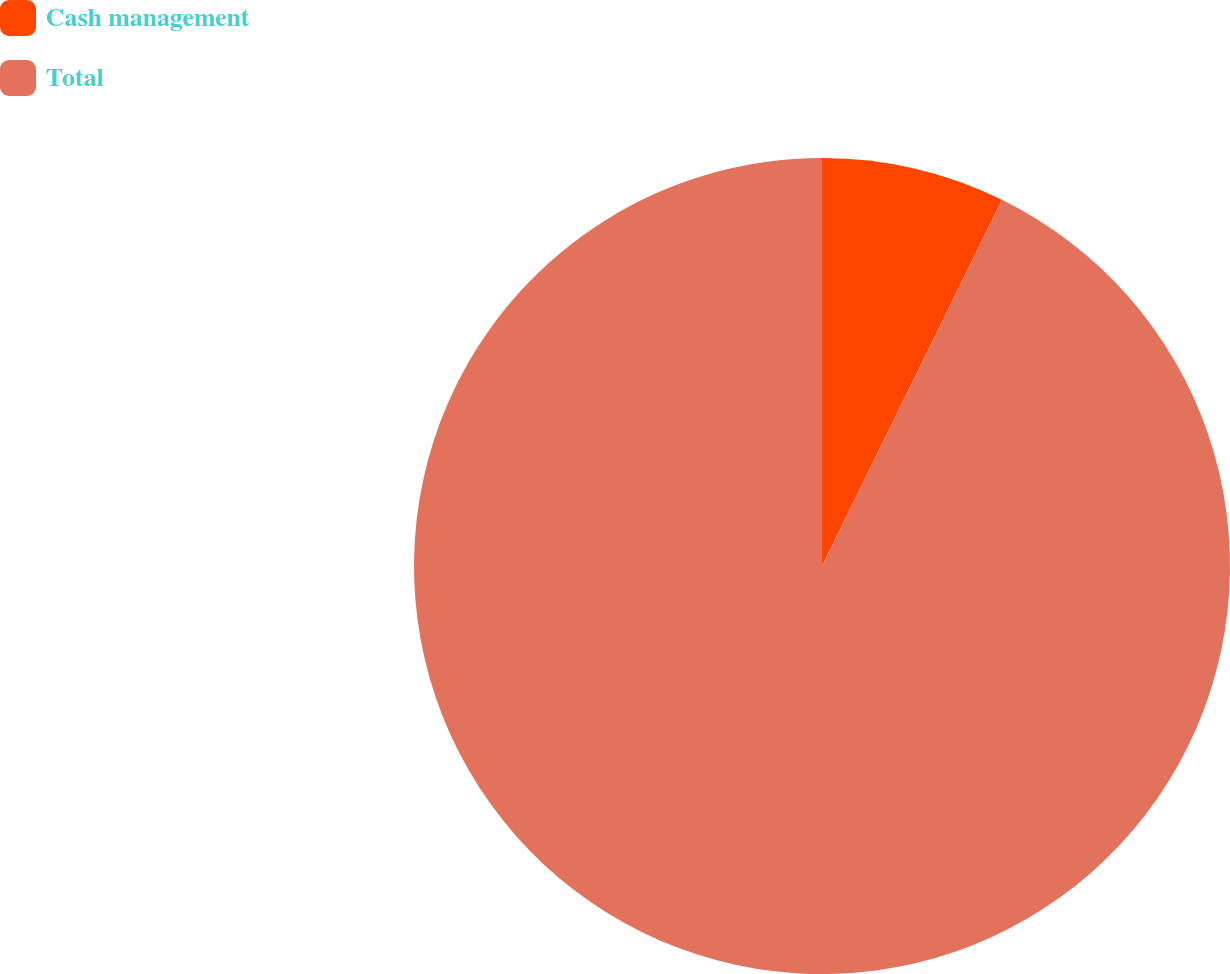<chart> <loc_0><loc_0><loc_500><loc_500><pie_chart><fcel>Cash management<fcel>Total<nl><fcel>7.27%<fcel>92.73%<nl></chart> 